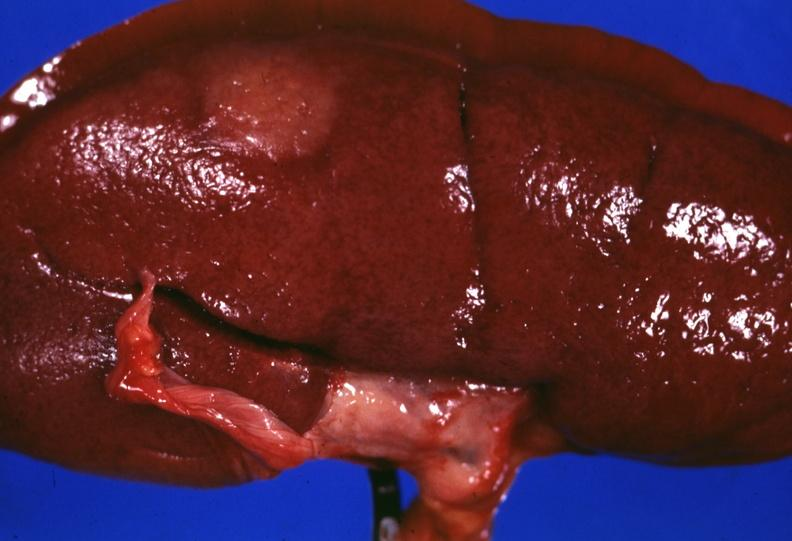what is present?
Answer the question using a single word or phrase. Sarcoidosis 